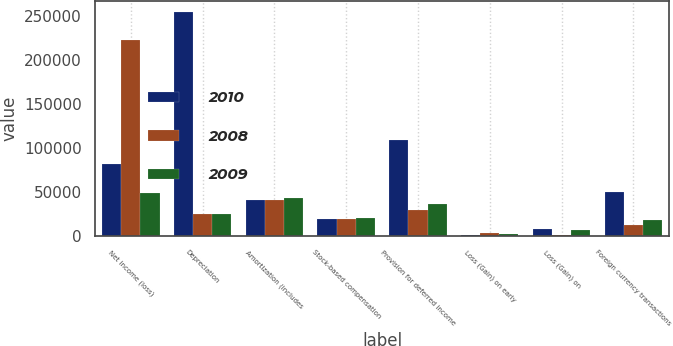Convert chart to OTSL. <chart><loc_0><loc_0><loc_500><loc_500><stacked_bar_chart><ecel><fcel>Net income (loss)<fcel>Depreciation<fcel>Amortization (includes<fcel>Stock-based compensation<fcel>Provision for deferred income<fcel>Loss (Gain) on early<fcel>Loss (Gain) on<fcel>Foreign currency transactions<nl><fcel>2010<fcel>81943<fcel>254619<fcel>41101<fcel>18988<fcel>109109<fcel>418<fcel>7483<fcel>50312<nl><fcel>2008<fcel>222306<fcel>25050.5<fcel>40618<fcel>18703<fcel>29723<fcel>3031<fcel>406<fcel>12686<nl><fcel>2009<fcel>48992<fcel>25050.5<fcel>42970<fcel>20378<fcel>35674<fcel>1792<fcel>6143<fcel>18105<nl></chart> 